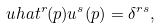<formula> <loc_0><loc_0><loc_500><loc_500>\ u h a t ^ { r } ( p ) u ^ { s } ( p ) = \delta ^ { r s } ,</formula> 